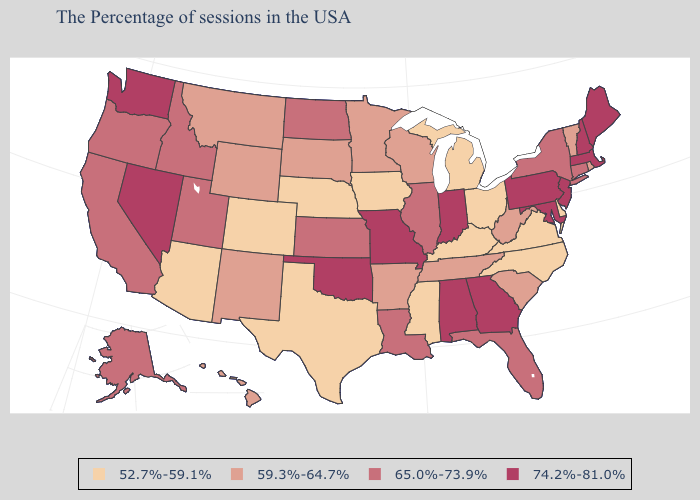What is the value of New York?
Short answer required. 65.0%-73.9%. Among the states that border Indiana , which have the highest value?
Be succinct. Illinois. Name the states that have a value in the range 52.7%-59.1%?
Give a very brief answer. Delaware, Virginia, North Carolina, Ohio, Michigan, Kentucky, Mississippi, Iowa, Nebraska, Texas, Colorado, Arizona. Name the states that have a value in the range 74.2%-81.0%?
Concise answer only. Maine, Massachusetts, New Hampshire, New Jersey, Maryland, Pennsylvania, Georgia, Indiana, Alabama, Missouri, Oklahoma, Nevada, Washington. What is the highest value in states that border Virginia?
Concise answer only. 74.2%-81.0%. What is the value of Michigan?
Be succinct. 52.7%-59.1%. Does the map have missing data?
Give a very brief answer. No. Does Maine have the highest value in the USA?
Quick response, please. Yes. Among the states that border Maine , which have the highest value?
Write a very short answer. New Hampshire. Among the states that border Maryland , does Virginia have the lowest value?
Concise answer only. Yes. Does Massachusetts have the lowest value in the USA?
Quick response, please. No. What is the value of Iowa?
Concise answer only. 52.7%-59.1%. What is the lowest value in states that border North Carolina?
Quick response, please. 52.7%-59.1%. Name the states that have a value in the range 74.2%-81.0%?
Quick response, please. Maine, Massachusetts, New Hampshire, New Jersey, Maryland, Pennsylvania, Georgia, Indiana, Alabama, Missouri, Oklahoma, Nevada, Washington. 